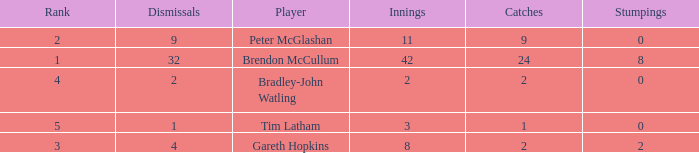How many stumpings did the player Tim Latham have? 0.0. 